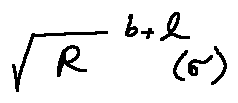Convert formula to latex. <formula><loc_0><loc_0><loc_500><loc_500>\sqrt { R } ^ { b + l } ( \sigma )</formula> 